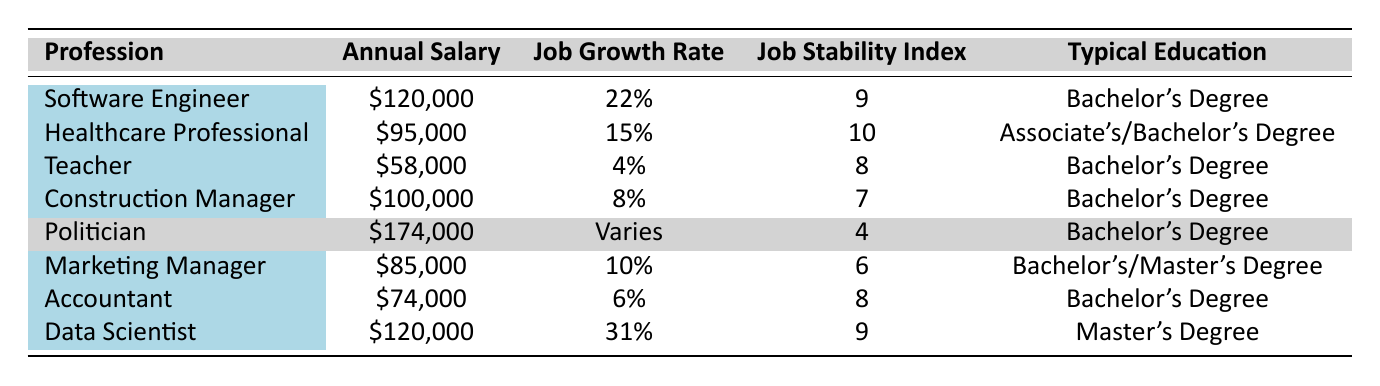What is the highest annual salary listed in the table? By inspecting the "Annual Salary" column, we can see that the maximum salary is for the profession of "Politician," which is listed as $174,000.
Answer: $174,000 Which profession requires the highest level of education? The "Data Scientist" position typically requires a "Master's Degree," which is the highest level of education listed in the table compared to other roles that require a Bachelor's or Associate's degree.
Answer: Data Scientist What is the job growth rate for a Teacher? The "Job Growth Rate" column for the profession "Teacher" shows a rate of 4%.
Answer: 4% Is a Healthcare Professional’s job stability index higher than that of a Politician? The "Job Stability Index" for a Healthcare Professional is 10 while for a Politician, it is 4. Since 10 is greater than 4, we conclude that the Healthcare Professional's stability index is indeed higher.
Answer: Yes What is the average annual salary of the professions listed besides Politician? The salaries excluding the Politician are: $120,000, $95,000, $58,000, $100,000, $85,000, and $74,000. Their total sum is $120,000 + $95,000 + $58,000 + $100,000 + $85,000 + $74,000 = $532,000. There are 6 professions, so the average is $532,000 / 6 = $88,666.67.
Answer: $88,667 Which profession has the lowest job growth rate? By looking at the "Job Growth Rate" column, "Teacher" has the lowest job growth rate at 4% compared to all other professions.
Answer: Teacher If you add the job stability indices of a Software Engineer and a Data Scientist, what is the result? The job stability index for Software Engineer is 9 and for Data Scientist is also 9. Adding these together gives 9 + 9 = 18.
Answer: 18 Is the job stability index for an Accountant higher than the job stability index for a Marketing Manager? The job stability index for Accountant is 8 and for Marketing Manager is 6. Since 8 is greater than 6, the index for Accountant is indeed higher.
Answer: Yes What is the difference in annual salary between a Construction Manager and a Healthcare Professional? The annual salary for Construction Manager is $100,000 and for Healthcare Professional is $95,000. The difference is $100,000 - $95,000 = $5,000.
Answer: $5,000 Which profession has the same job stability index as that of a Data Scientist? The job stability index for Data Scientist is 9. The profession with the same index is Software Engineer, which also has a job stability index of 9.
Answer: Software Engineer 